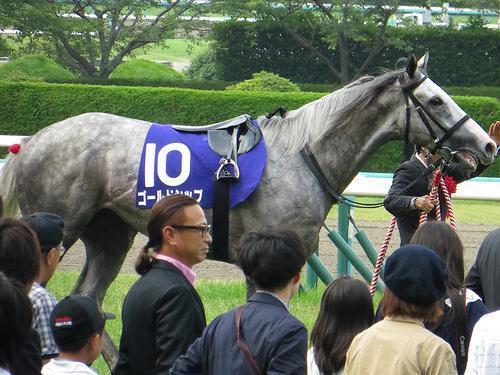How many people are in the crowd?
Give a very brief answer. 11. 